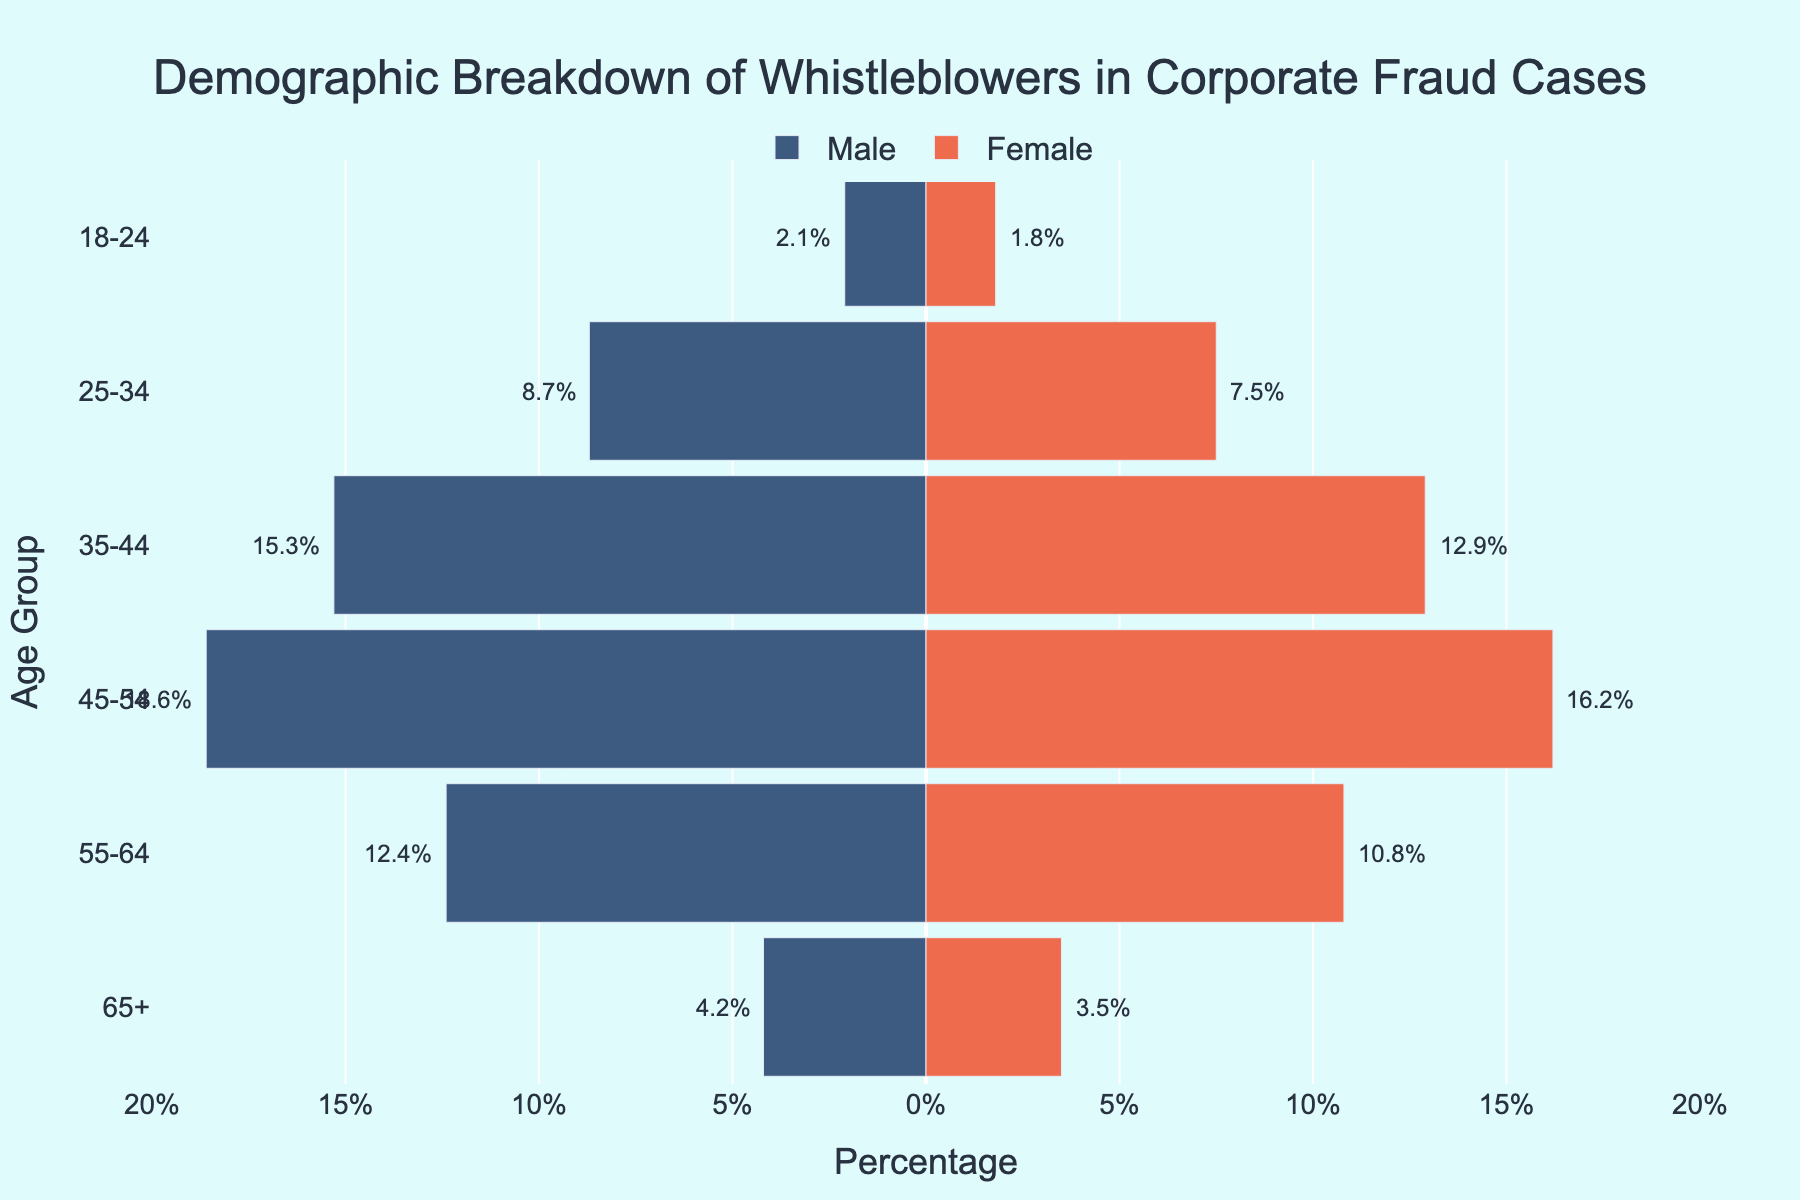What's the title of the figure? The title is typically placed at the top of the figure and is meant to summarize the information presented in the visual. In this case, the title is clearly stated.
Answer: Demographic Breakdown of Whistleblowers in Corporate Fraud Cases How many age groups are represented in the figure? By observing the y-axis, we can count the distinct age groups listed. Each age group is written as ranges, like '18-24', '25-34', etc.
Answer: 6 What percentage of whistleblowers aged 45-54 are male? The horizontal bar corresponding to males in the '45-54' age group extends to 18.6% on the negative x-axis.
Answer: 18.6% Which age group has the highest percentage of female whistleblowers? By comparing the lengths of the female bars across all age groups, we can identify the age group with the longest bar. The '45-54' age group has the longest bar for females.
Answer: 45-54 In the 35-44 age group, is the percentage of male whistleblowers higher or lower than that of female whistleblowers? By looking at the lengths of the corresponding bars in the '35-44' age group, we can compare the male and female bar lengths. The male bar is longer.
Answer: Higher What is the total percentage of whistleblowers aged 25-34? We need to sum the percentages of male (8.7%) and female (7.5%) whistleblowers in the '25-34' age group. 8.7% + 7.5% = 16.2%.
Answer: 16.2% How does the percentage of male whistleblowers aged 55-64 compare to those aged 65+? By comparing the lengths of the male bars for the '55-64' and '65+' age groups, we see that the '55-64' bar is longer. 12.4% is greater than 4.2%.
Answer: 55-64 is higher What percentage of total whistleblowers are aged 18-24? We sum the percentages of male (2.1%) and female (1.8%) whistleblowers in the '18-24' age group. 2.1% + 1.8% = 3.9%.
Answer: 3.9% Which gender has a higher percentage of whistleblowers overall? We compare the sum of the percentages for all male and female categories. Summing male values: 2.1% + 8.7% + 15.3% + 18.6% + 12.4% + 4.2% = 61.3%. Summing female values: 1.8% + 7.5% + 12.9% + 16.2% + 10.8% + 3.5% = 52.7%.
Answer: Male What is the ratio of male to female whistleblowers in the 45-54 age group? The percentages are 18.6% for males and 16.2% for females. The ratio is obtained by dividing 18.6 by 16.2. 18.6 / 16.2 ≈ 1.15.
Answer: 1.15 